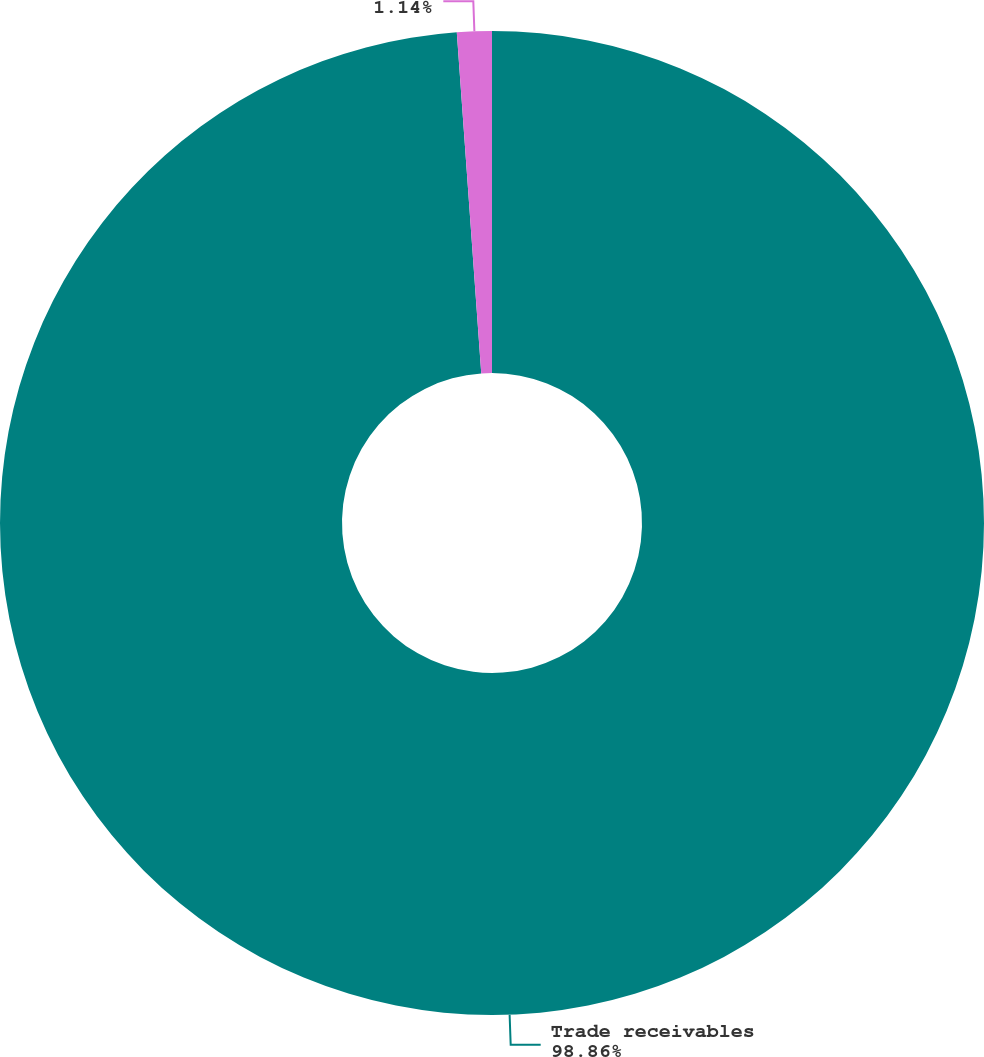<chart> <loc_0><loc_0><loc_500><loc_500><pie_chart><fcel>Trade receivables<fcel>Allowance for doubtful<nl><fcel>98.86%<fcel>1.14%<nl></chart> 